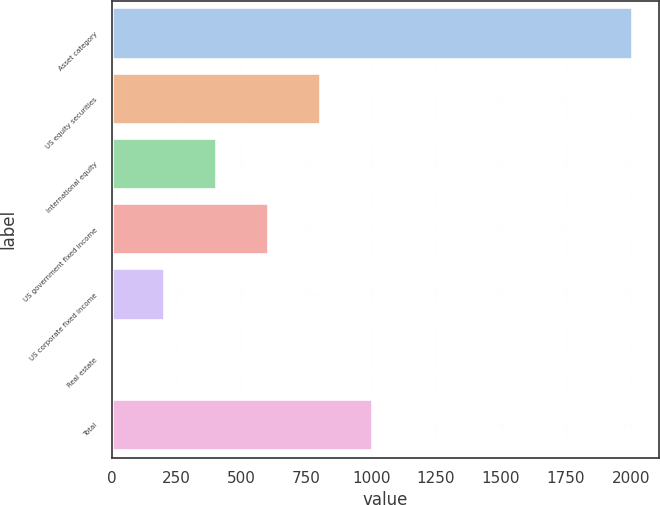<chart> <loc_0><loc_0><loc_500><loc_500><bar_chart><fcel>Asset category<fcel>US equity securities<fcel>International equity<fcel>US government fixed income<fcel>US corporate fixed income<fcel>Real estate<fcel>Total<nl><fcel>2008<fcel>805.6<fcel>404.8<fcel>605.2<fcel>204.4<fcel>4<fcel>1006<nl></chart> 